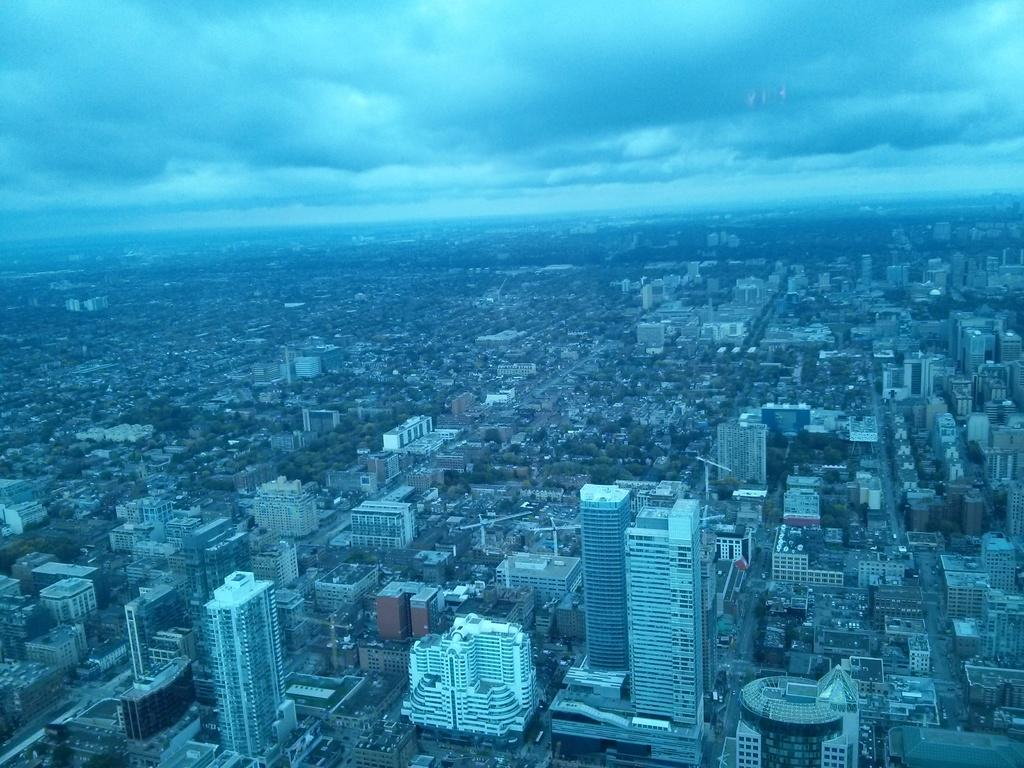What type of location is depicted in the image? The image shows a view of the city. What are some of the prominent features of the cityscape? There are skyscrapers and other buildings in the image. Are there any natural elements visible in the image? Yes, there are trees visible in the image. What is the condition of the sky in the image? Clouds are present in the sky in the image. How many cows can be seen grazing in the cityscape? There are no cows present in the image; it depicts a view of the city with skyscrapers, buildings, trees, and clouds. 